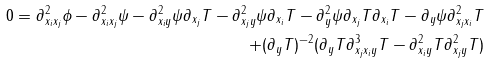Convert formula to latex. <formula><loc_0><loc_0><loc_500><loc_500>0 = \partial ^ { 2 } _ { x _ { i } x _ { j } } \phi - \partial ^ { 2 } _ { x _ { i } x _ { j } } \psi - \partial ^ { 2 } _ { x _ { i } y } \psi \partial _ { x _ { j } } T - \partial ^ { 2 } _ { x _ { j } y } \psi \partial _ { x _ { i } } T - \partial ^ { 2 } _ { y } \psi \partial _ { x _ { j } } T \partial _ { x _ { i } } T - \partial _ { y } \psi \partial ^ { 2 } _ { x _ { j } x _ { i } } T \\ + { ( \partial _ { y } T ) ^ { - 2 } } ( \partial _ { y } T \partial ^ { 3 } _ { x _ { j } x _ { i } y } T - \partial ^ { 2 } _ { x _ { i } y } T \partial ^ { 2 } _ { x _ { j } y } T )</formula> 